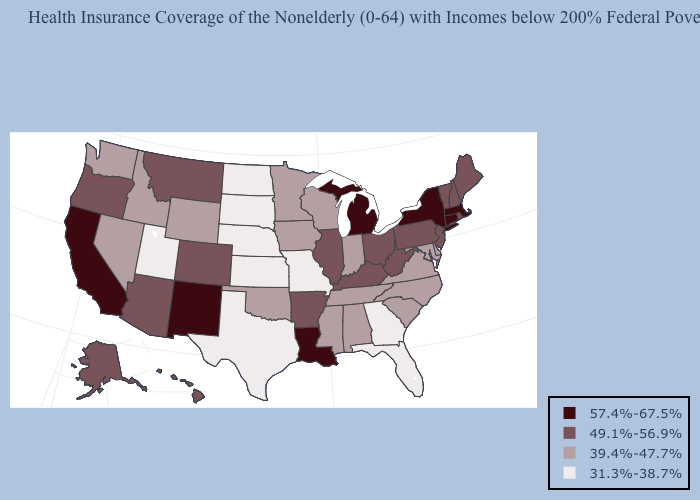Name the states that have a value in the range 31.3%-38.7%?
Be succinct. Florida, Georgia, Kansas, Missouri, Nebraska, North Dakota, South Dakota, Texas, Utah. Among the states that border Massachusetts , which have the lowest value?
Give a very brief answer. New Hampshire, Rhode Island, Vermont. Is the legend a continuous bar?
Be succinct. No. What is the lowest value in states that border Texas?
Keep it brief. 39.4%-47.7%. Does Nebraska have a higher value than Kansas?
Give a very brief answer. No. What is the lowest value in the USA?
Concise answer only. 31.3%-38.7%. What is the lowest value in states that border Louisiana?
Give a very brief answer. 31.3%-38.7%. What is the value of Indiana?
Quick response, please. 39.4%-47.7%. Among the states that border Nebraska , does Wyoming have the highest value?
Answer briefly. No. Does the first symbol in the legend represent the smallest category?
Write a very short answer. No. Which states hav the highest value in the Northeast?
Be succinct. Connecticut, Massachusetts, New York. Does the map have missing data?
Concise answer only. No. What is the highest value in the USA?
Answer briefly. 57.4%-67.5%. What is the lowest value in the West?
Write a very short answer. 31.3%-38.7%. What is the highest value in the USA?
Keep it brief. 57.4%-67.5%. 